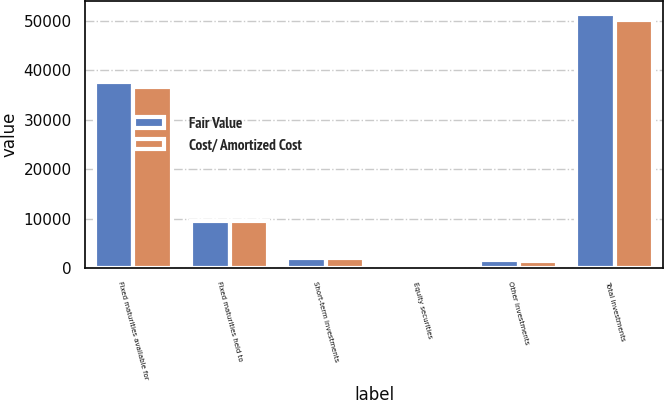<chart> <loc_0><loc_0><loc_500><loc_500><stacked_bar_chart><ecel><fcel>Fixed maturities available for<fcel>Fixed maturities held to<fcel>Short-term investments<fcel>Equity securities<fcel>Other investments<fcel>Total investments<nl><fcel>Fair Value<fcel>37539<fcel>9461<fcel>1983<fcel>692<fcel>1692<fcel>51367<nl><fcel>Cost/ Amortized Cost<fcel>36542<fcel>9501<fcel>1983<fcel>666<fcel>1511<fcel>50203<nl></chart> 